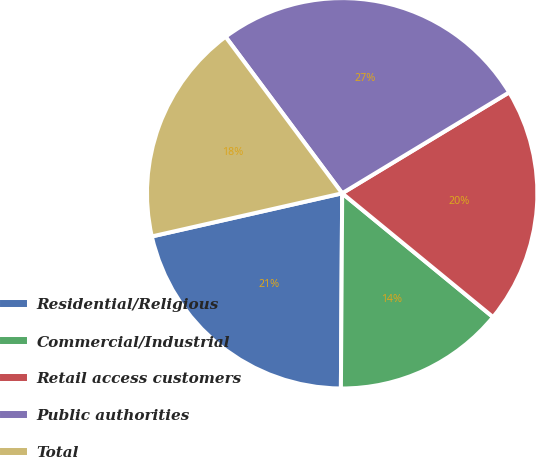Convert chart to OTSL. <chart><loc_0><loc_0><loc_500><loc_500><pie_chart><fcel>Residential/Religious<fcel>Commercial/Industrial<fcel>Retail access customers<fcel>Public authorities<fcel>Total<nl><fcel>21.35%<fcel>14.17%<fcel>19.59%<fcel>26.54%<fcel>18.36%<nl></chart> 